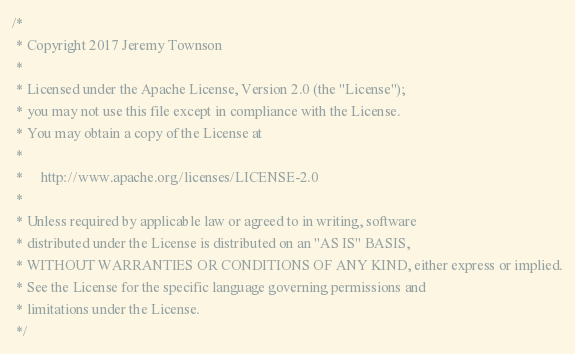<code> <loc_0><loc_0><loc_500><loc_500><_Scala_>/*
 * Copyright 2017 Jeremy Townson
 *
 * Licensed under the Apache License, Version 2.0 (the "License");
 * you may not use this file except in compliance with the License.
 * You may obtain a copy of the License at
 *
 *     http://www.apache.org/licenses/LICENSE-2.0
 *
 * Unless required by applicable law or agreed to in writing, software
 * distributed under the License is distributed on an "AS IS" BASIS,
 * WITHOUT WARRANTIES OR CONDITIONS OF ANY KIND, either express or implied.
 * See the License for the specific language governing permissions and
 * limitations under the License.
 */
</code> 